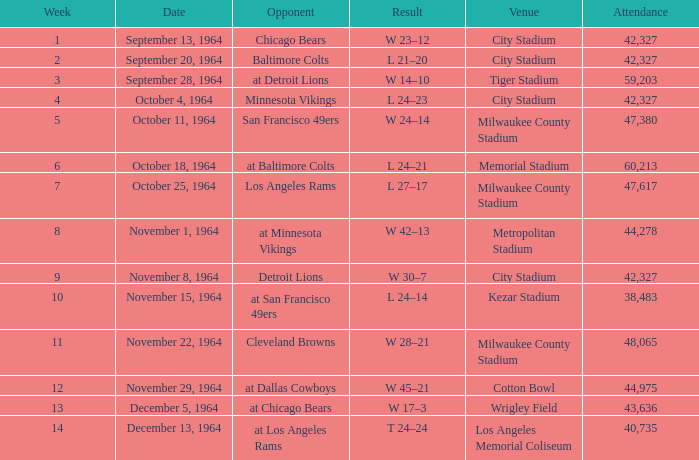What is the average attendance at a week 4 game? 42327.0. 